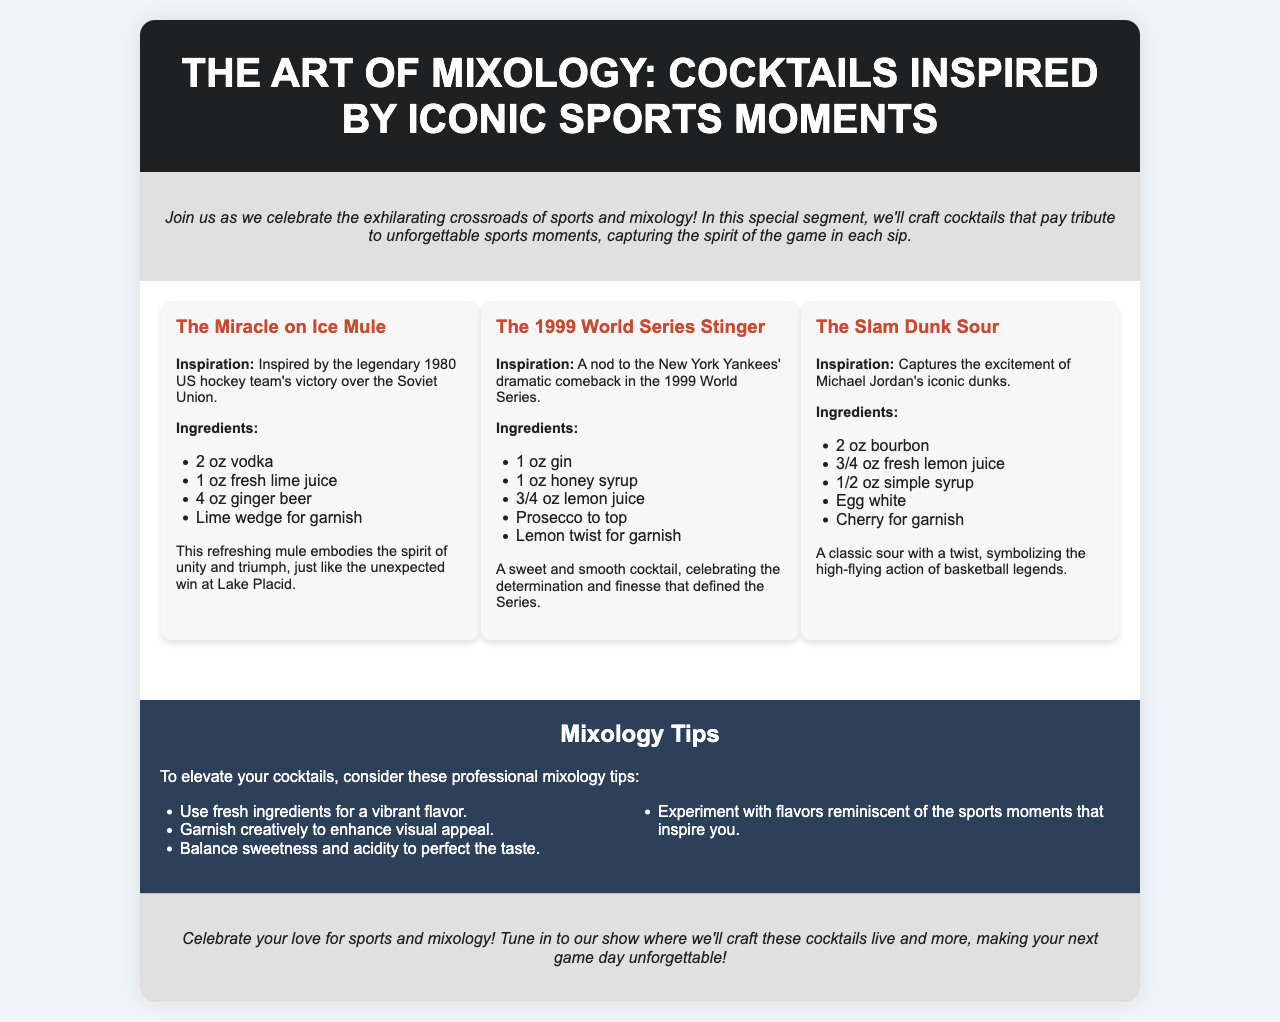what is the title of the brochure? The title is prominently displayed in the header section of the document.
Answer: The Art of Mixology: Cocktails Inspired by Iconic Sports Moments how many cocktails are featured in the document? The document lists three unique cocktail recipes in the cocktails section.
Answer: Three what is the first cocktail mentioned in the document? The first cocktail is featured in the cocktails section with its name prominently displayed.
Answer: The Miracle on Ice Mule which sports event inspired The 1999 World Series Stinger? The inspiration for this cocktail is clearly stated in its description.
Answer: New York Yankees' dramatic comeback in the 1999 World Series name an ingredient in The Slam Dunk Sour. The ingredient list under The Slam Dunk Sour provides specific components for the cocktail.
Answer: Bourbon what key element should be balanced according to the mixology tips? The mixology tips section highlights important aspects in crafting cocktails, including balance.
Answer: Sweetness and acidity how can you enhance visual appeal in cocktails? The mixology tips provide practical advice for presentation.
Answer: Garnish creatively what type of drink is inspired by Michael Jordan's iconic dunks? The description of the cocktail will reveal its name and inspiration tied to basketball.
Answer: The Slam Dunk Sour what kind of beverage is used in The Miracle on Ice Mule? The ingredient list for this cocktail specifies the type of beverage included.
Answer: Ginger beer 